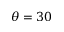Convert formula to latex. <formula><loc_0><loc_0><loc_500><loc_500>\theta = 3 0</formula> 